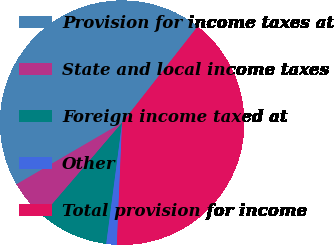<chart> <loc_0><loc_0><loc_500><loc_500><pie_chart><fcel>Provision for income taxes at<fcel>State and local income taxes<fcel>Foreign income taxed at<fcel>Other<fcel>Total provision for income<nl><fcel>44.0%<fcel>5.3%<fcel>9.22%<fcel>1.39%<fcel>40.09%<nl></chart> 